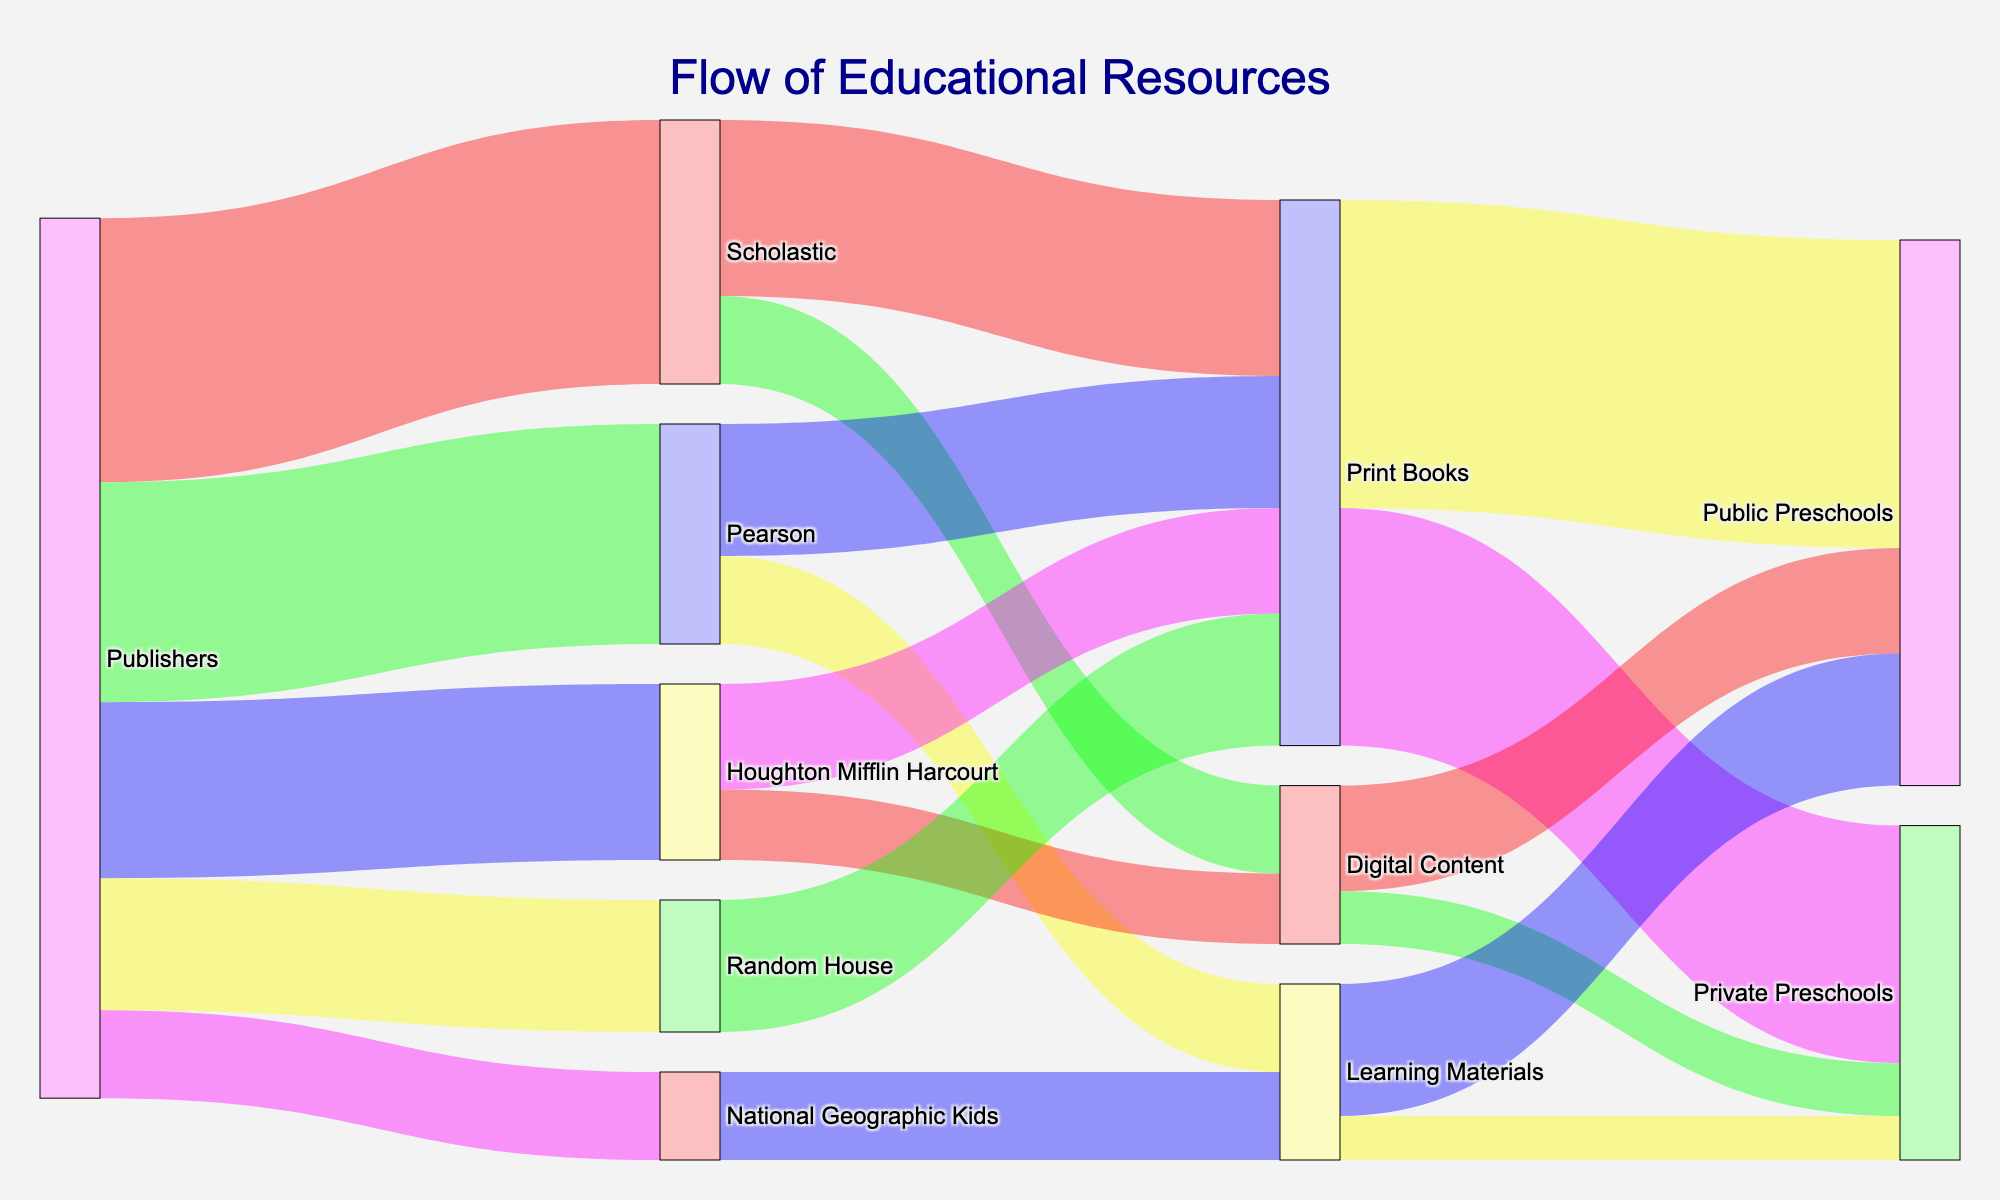Which publisher flows the most educational resources? The Publishers node with the highest linked values is Scholastic with a total value of 30. This indicates that Scholastic has the largest flow of educational resources from publishers.
Answer: Scholastic Which type of resource is sent the most to public preschools? Print Books have the highest cumulative value (35) flowing to Public Preschools, compared to Digital Content (12) and Learning Materials (15).
Answer: Print Books How many total educational resources flow from Pearson to preschools? Pearson sends Print Books (15), then these Print Books flow into Public Preschools (35) and Private Preschools (27), summing to 62. Additionally, Pearson sends Learning Materials (10), splitting into Public Preschools (15) and Private Preschools (5). So, the total is 62 + 25 = 87.
Answer: 87 What is the total flow of digital content to preschools? Digital Content flows from Scholastic (10) and Houghton Mifflin Harcourt (8) into Public Preschools (12) and Private Preschools (6), summing up to 12 + 6 = 18.
Answer: 18 Which type of resource does Scholastic provide the most? Scholastic's flow shows Print Books with a value of 20 and Digital Content with a value of 10. Therefore, Print Books have the highest value.
Answer: Print Books How many resources does Houghton Mifflin Harcourt distribute digitally? Houghton Mifflin Harcourt has a Digital Content flow value of 8.
Answer: 8 Compare the amount of Print Books flowing to Public vs. Private Preschools. Print Books flow 35 to Public Preschools and 27 to Private Preschools. So, more books flow to Public Preschools.
Answer: Public Preschools What is the overall total of resources flowing to Public Preschools from all types? Sum the flows: Print Books (35), Digital Content (12), and Learning Materials (15), which equals 35 + 12 + 15 = 62.
Answer: 62 How does the flow of National Geographic Kids' Learning Materials split between public and private preschools? Learning Materials from National Geographic Kids have a value of 10, flowing entirely to Learning Materials. This splits into Public (15) and Private (5).
Answer: Public: 15, Private: 5 